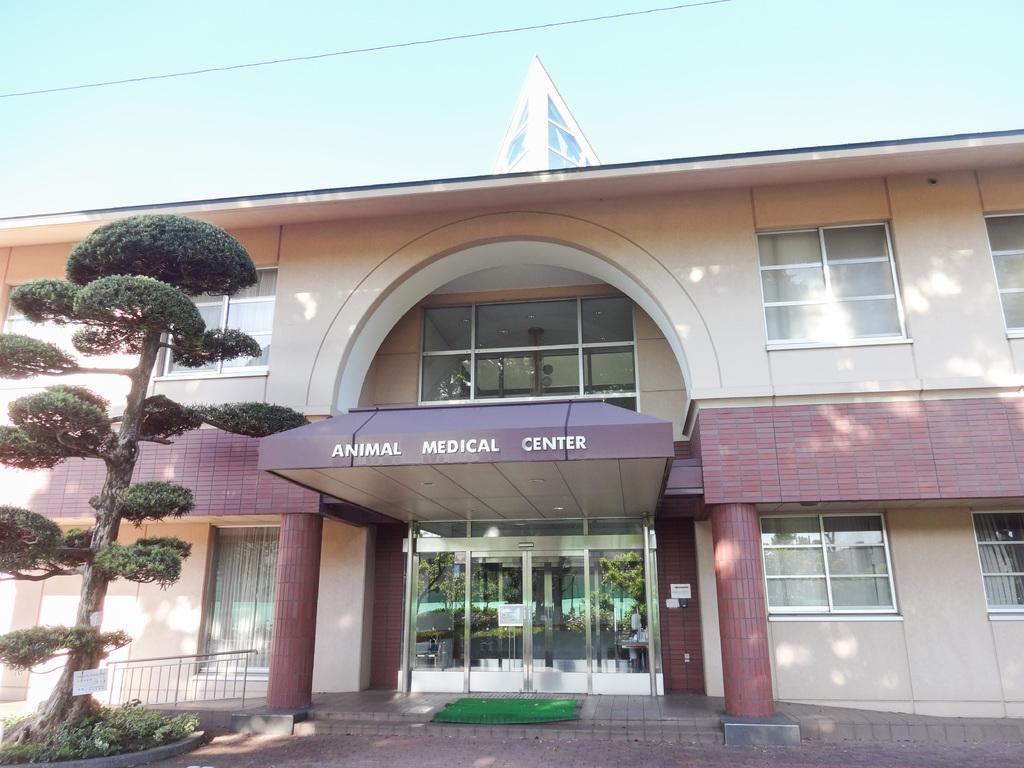Describe this image in one or two sentences. In this image I can see the building and to the building I can see the name animal medical center is written on it. To the left I can see the tree. In the back there is a blue sky. 